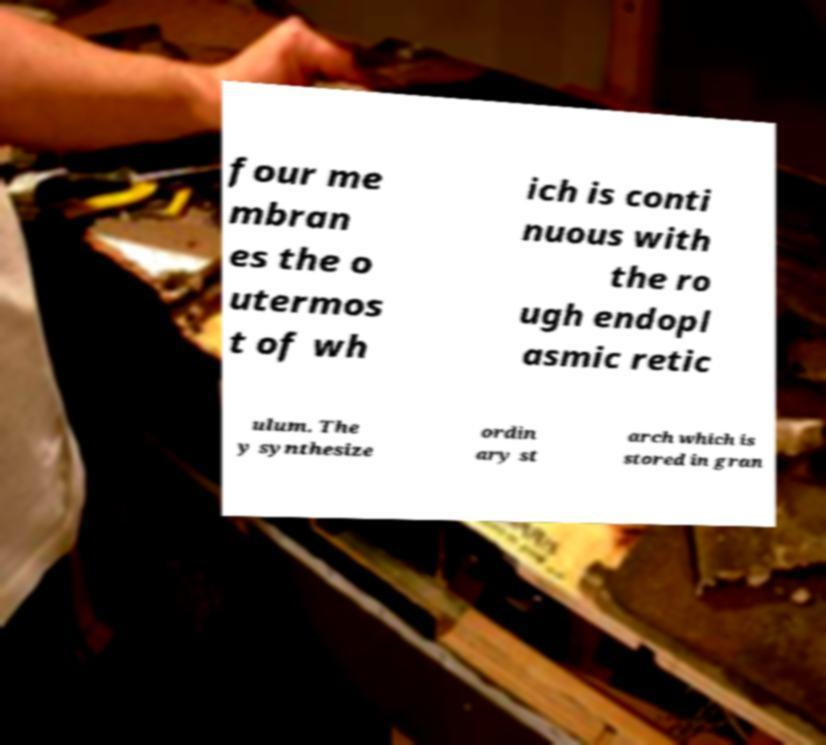I need the written content from this picture converted into text. Can you do that? four me mbran es the o utermos t of wh ich is conti nuous with the ro ugh endopl asmic retic ulum. The y synthesize ordin ary st arch which is stored in gran 